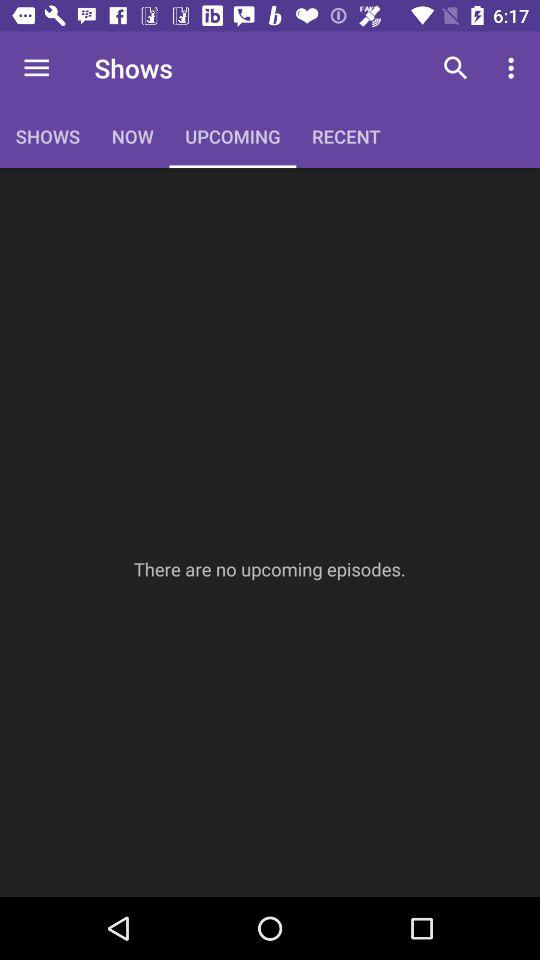How many episodes are there in the "Upcoming" tab?
Answer the question using a single word or phrase. 0 